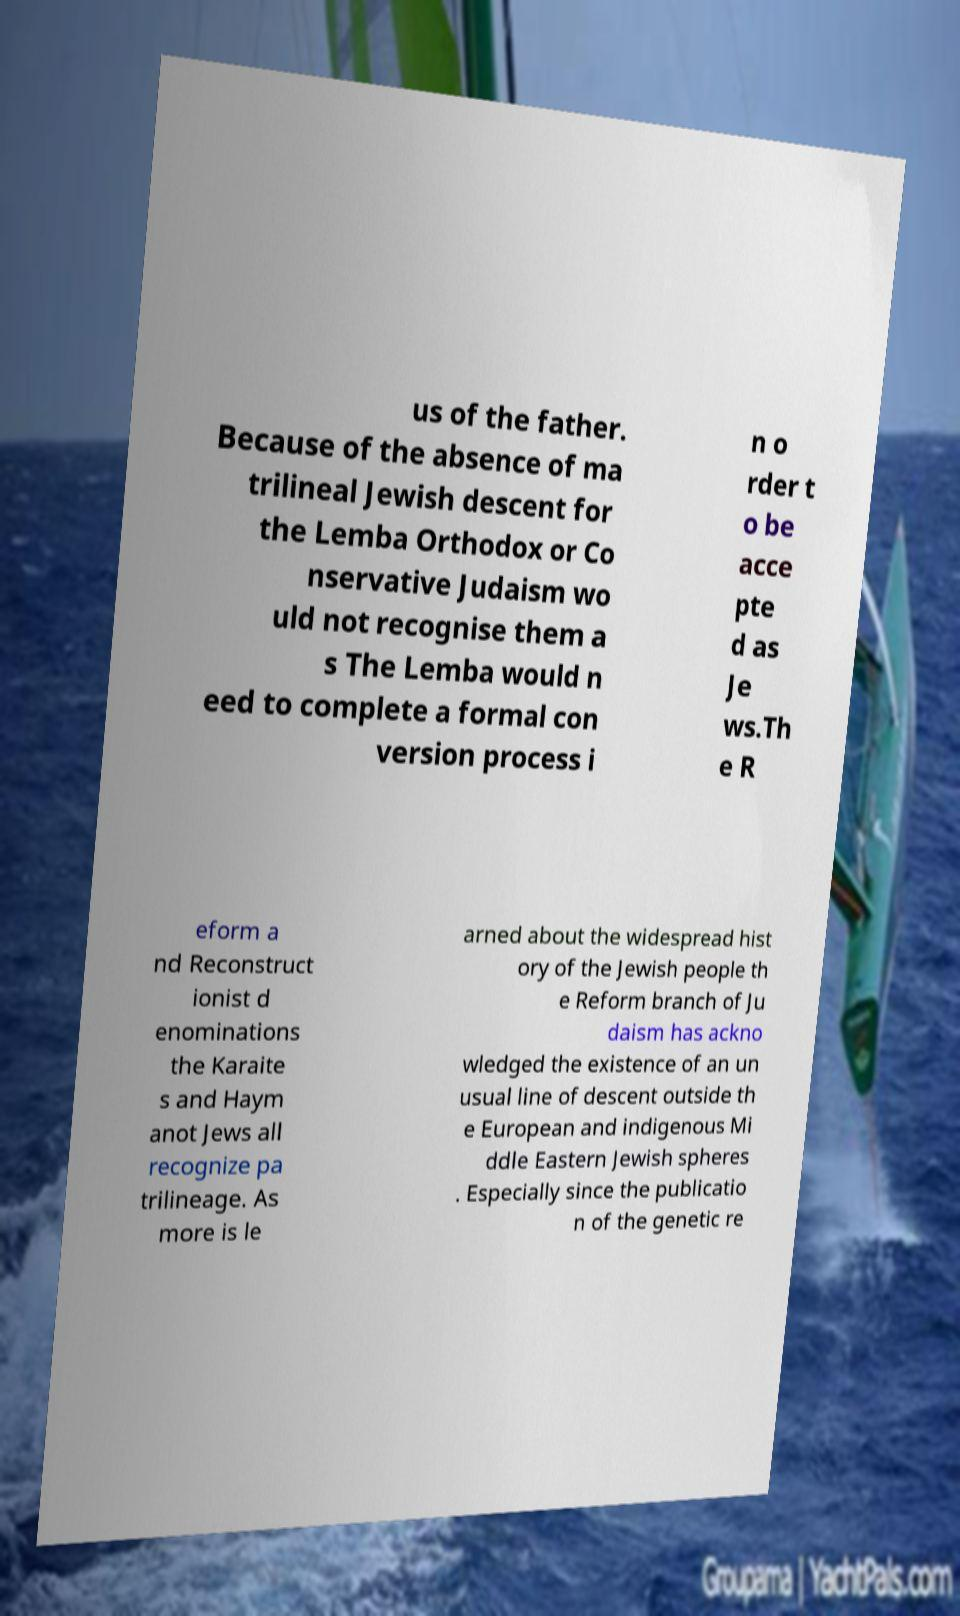There's text embedded in this image that I need extracted. Can you transcribe it verbatim? us of the father. Because of the absence of ma trilineal Jewish descent for the Lemba Orthodox or Co nservative Judaism wo uld not recognise them a s The Lemba would n eed to complete a formal con version process i n o rder t o be acce pte d as Je ws.Th e R eform a nd Reconstruct ionist d enominations the Karaite s and Haym anot Jews all recognize pa trilineage. As more is le arned about the widespread hist ory of the Jewish people th e Reform branch of Ju daism has ackno wledged the existence of an un usual line of descent outside th e European and indigenous Mi ddle Eastern Jewish spheres . Especially since the publicatio n of the genetic re 